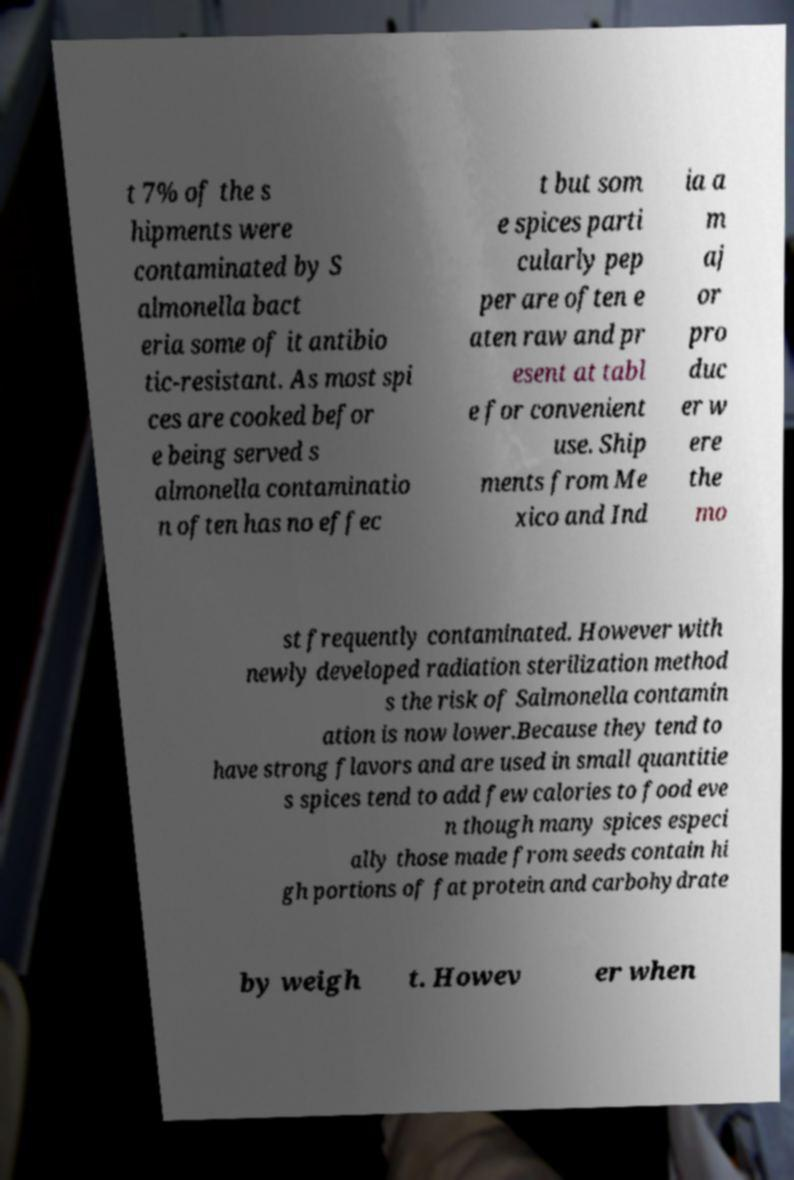I need the written content from this picture converted into text. Can you do that? t 7% of the s hipments were contaminated by S almonella bact eria some of it antibio tic-resistant. As most spi ces are cooked befor e being served s almonella contaminatio n often has no effec t but som e spices parti cularly pep per are often e aten raw and pr esent at tabl e for convenient use. Ship ments from Me xico and Ind ia a m aj or pro duc er w ere the mo st frequently contaminated. However with newly developed radiation sterilization method s the risk of Salmonella contamin ation is now lower.Because they tend to have strong flavors and are used in small quantitie s spices tend to add few calories to food eve n though many spices especi ally those made from seeds contain hi gh portions of fat protein and carbohydrate by weigh t. Howev er when 